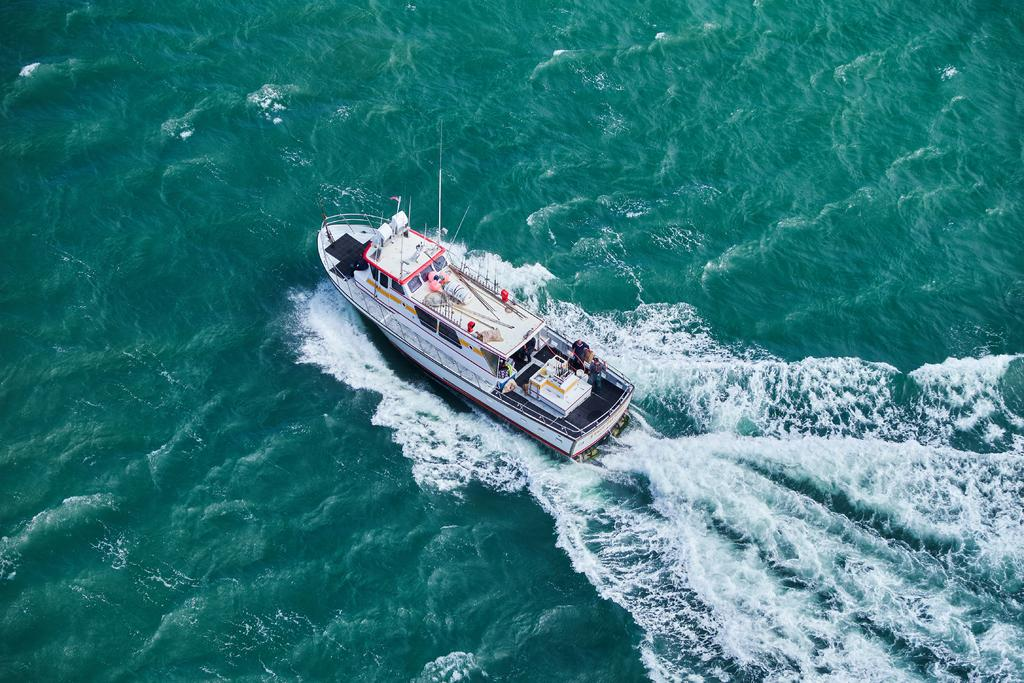What is the main subject of the image? The main subject of the image is a boat. Where is the boat located in the image? The boat is in the water. What type of beam can be seen supporting the boat in the image? There is no beam present in the image; the boat is simply floating in the water. What type of quilt is covering the boat in the image? There is no quilt present in the image; the boat is in the water without any covering. 